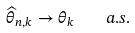Convert formula to latex. <formula><loc_0><loc_0><loc_500><loc_500>\widehat { \theta } _ { n , k } \to \theta _ { k } \quad a . s .</formula> 